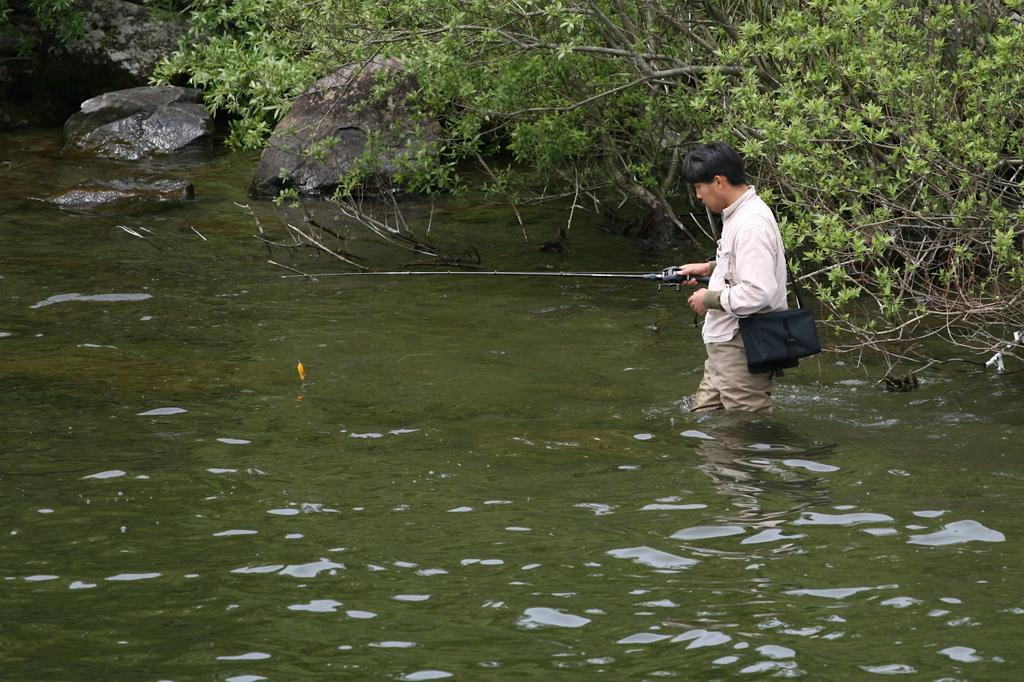What is the person in the image doing? The person is standing in the water. What object is the person holding? The person is holding a stick. What can be seen in the background of the image? There are trees visible in the background of the image. How many frogs are sitting on the person's head in the image? There are no frogs present in the image, so it is impossible to determine how many might be sitting on the person's head. 